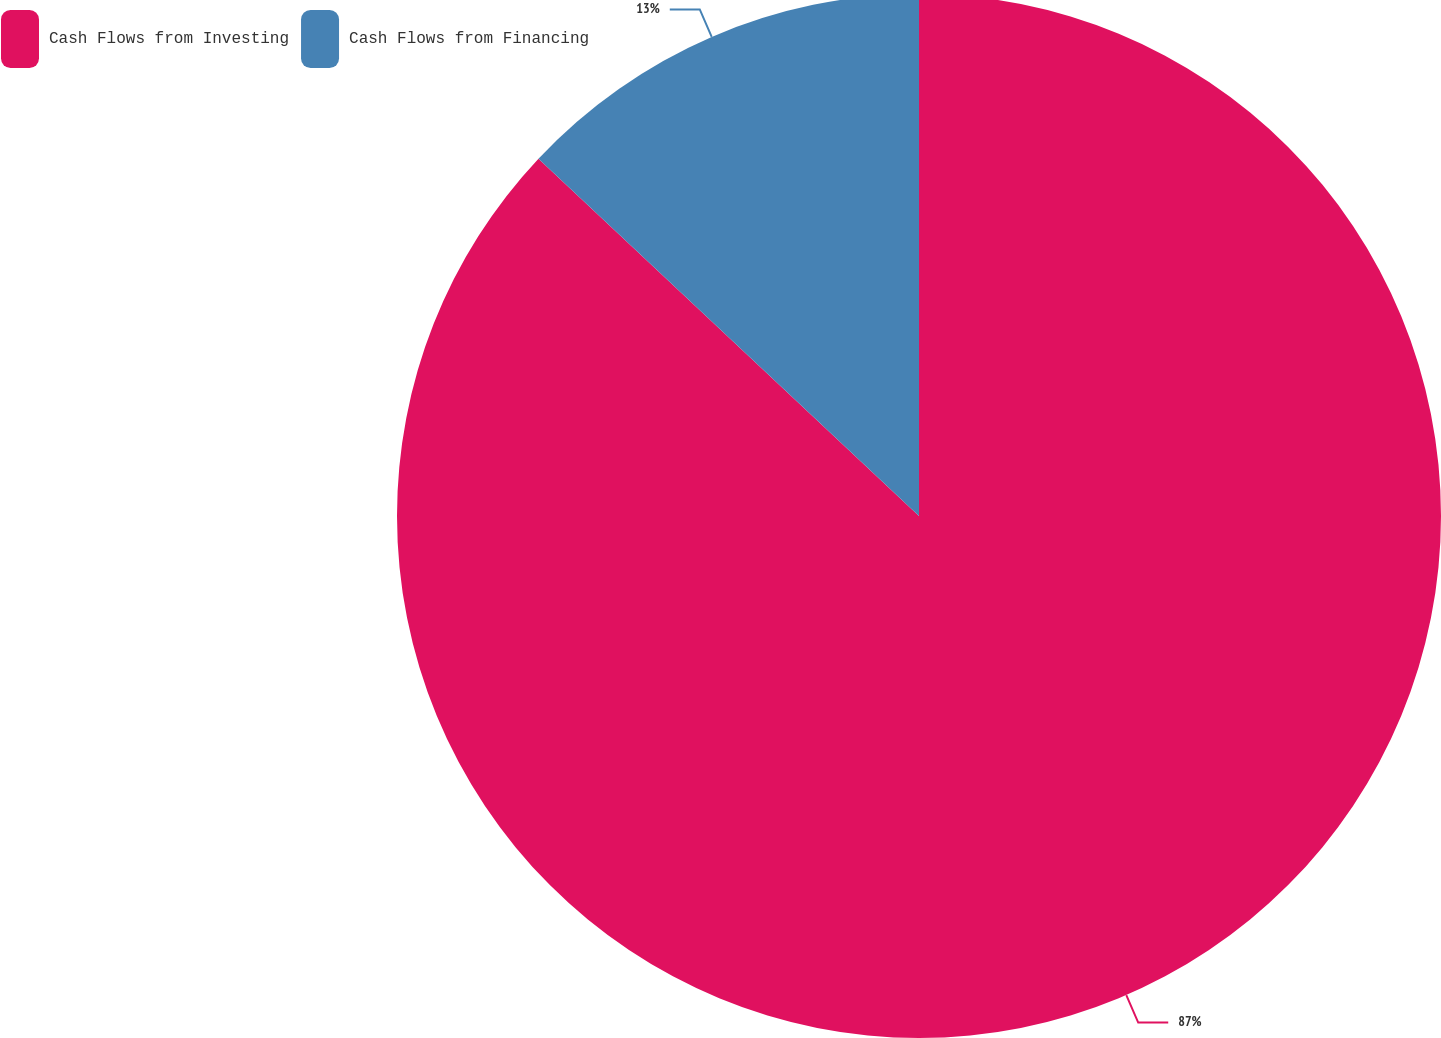Convert chart. <chart><loc_0><loc_0><loc_500><loc_500><pie_chart><fcel>Cash Flows from Investing<fcel>Cash Flows from Financing<nl><fcel>87.0%<fcel>13.0%<nl></chart> 